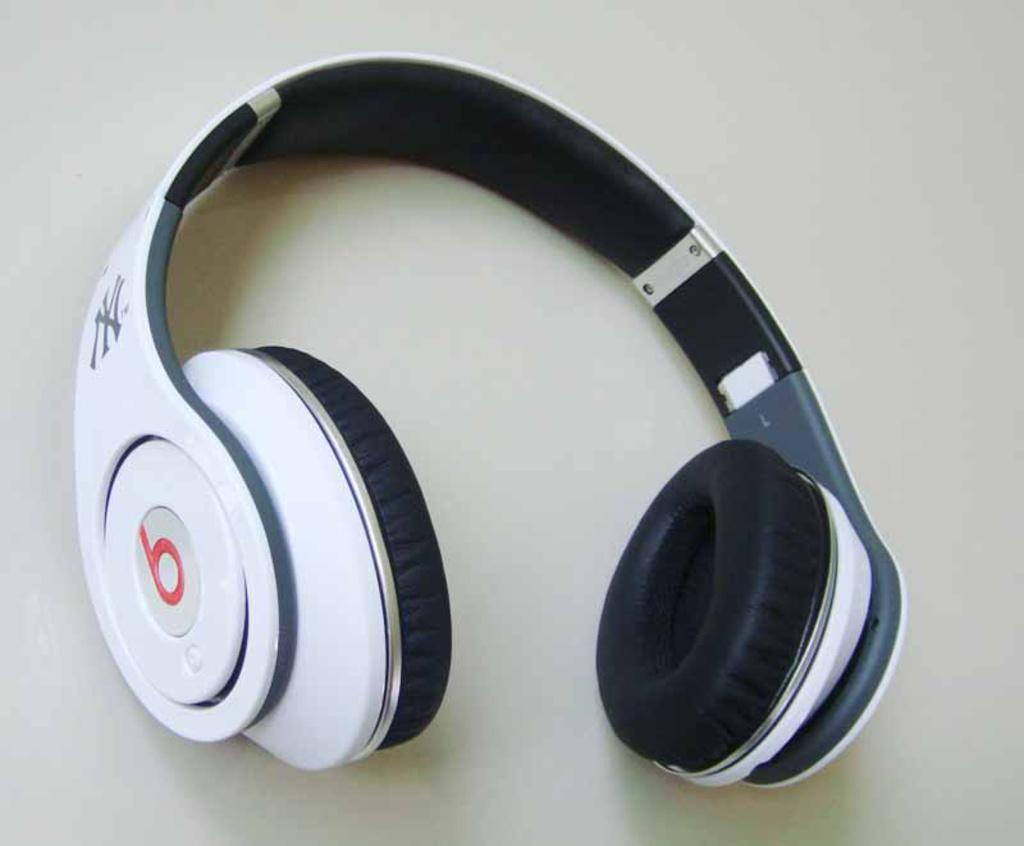What type of device is visible in the image? There is a headset in the image. What colors are used for the headset? The headset is black and white in color. Is there any text or lettering on the headset? Yes, the letter "B" is written on the headset. On what surface is the headset placed? The headset is on a surface. What type of noise can be heard coming from the moon in the image? There is no moon present in the image, and therefore no noise can be heard coming from it. 